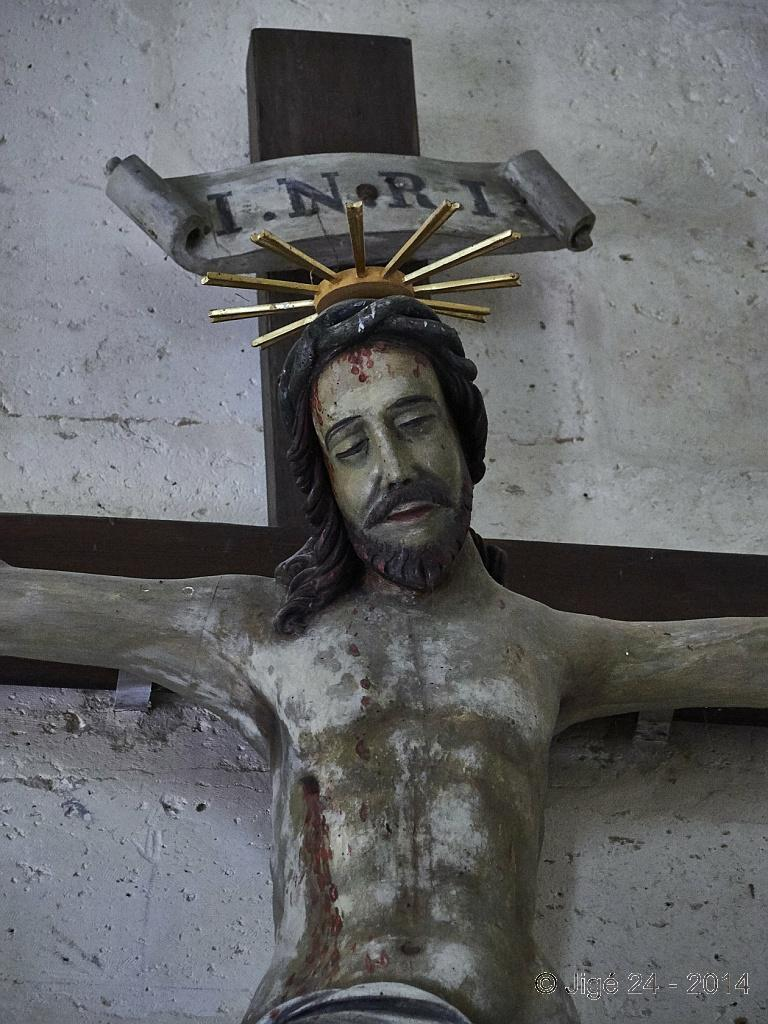What is the main subject in the image? There is a sculpture in the image. What can be seen in the background of the image? There is a well in the background of the image. Where is the text located in the image? The text is at the bottom of the image. How many babies are present in the image? There are no babies present in the image. What shape is the desire depicted in the image? There is no desire depicted in the image. 